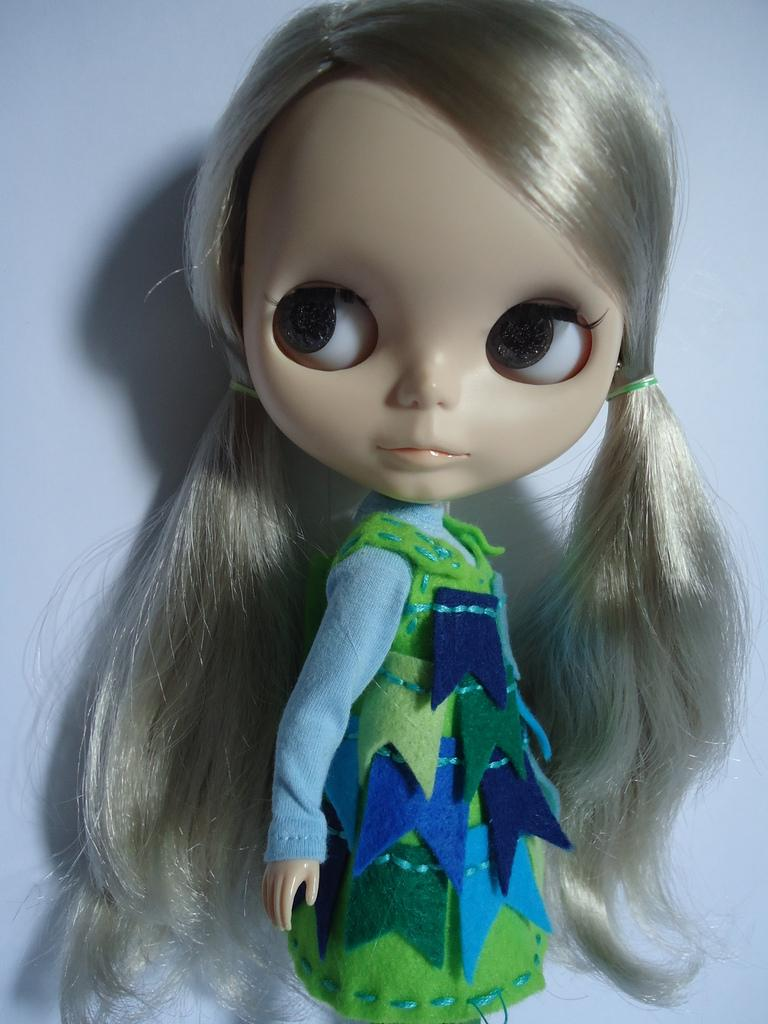What is the main subject in the image? There is a doll in the image. What color is the background of the image? The background of the image is white. Can you hear the doll laughing in the image? The image is silent, and there is no sound or indication of laughter. 